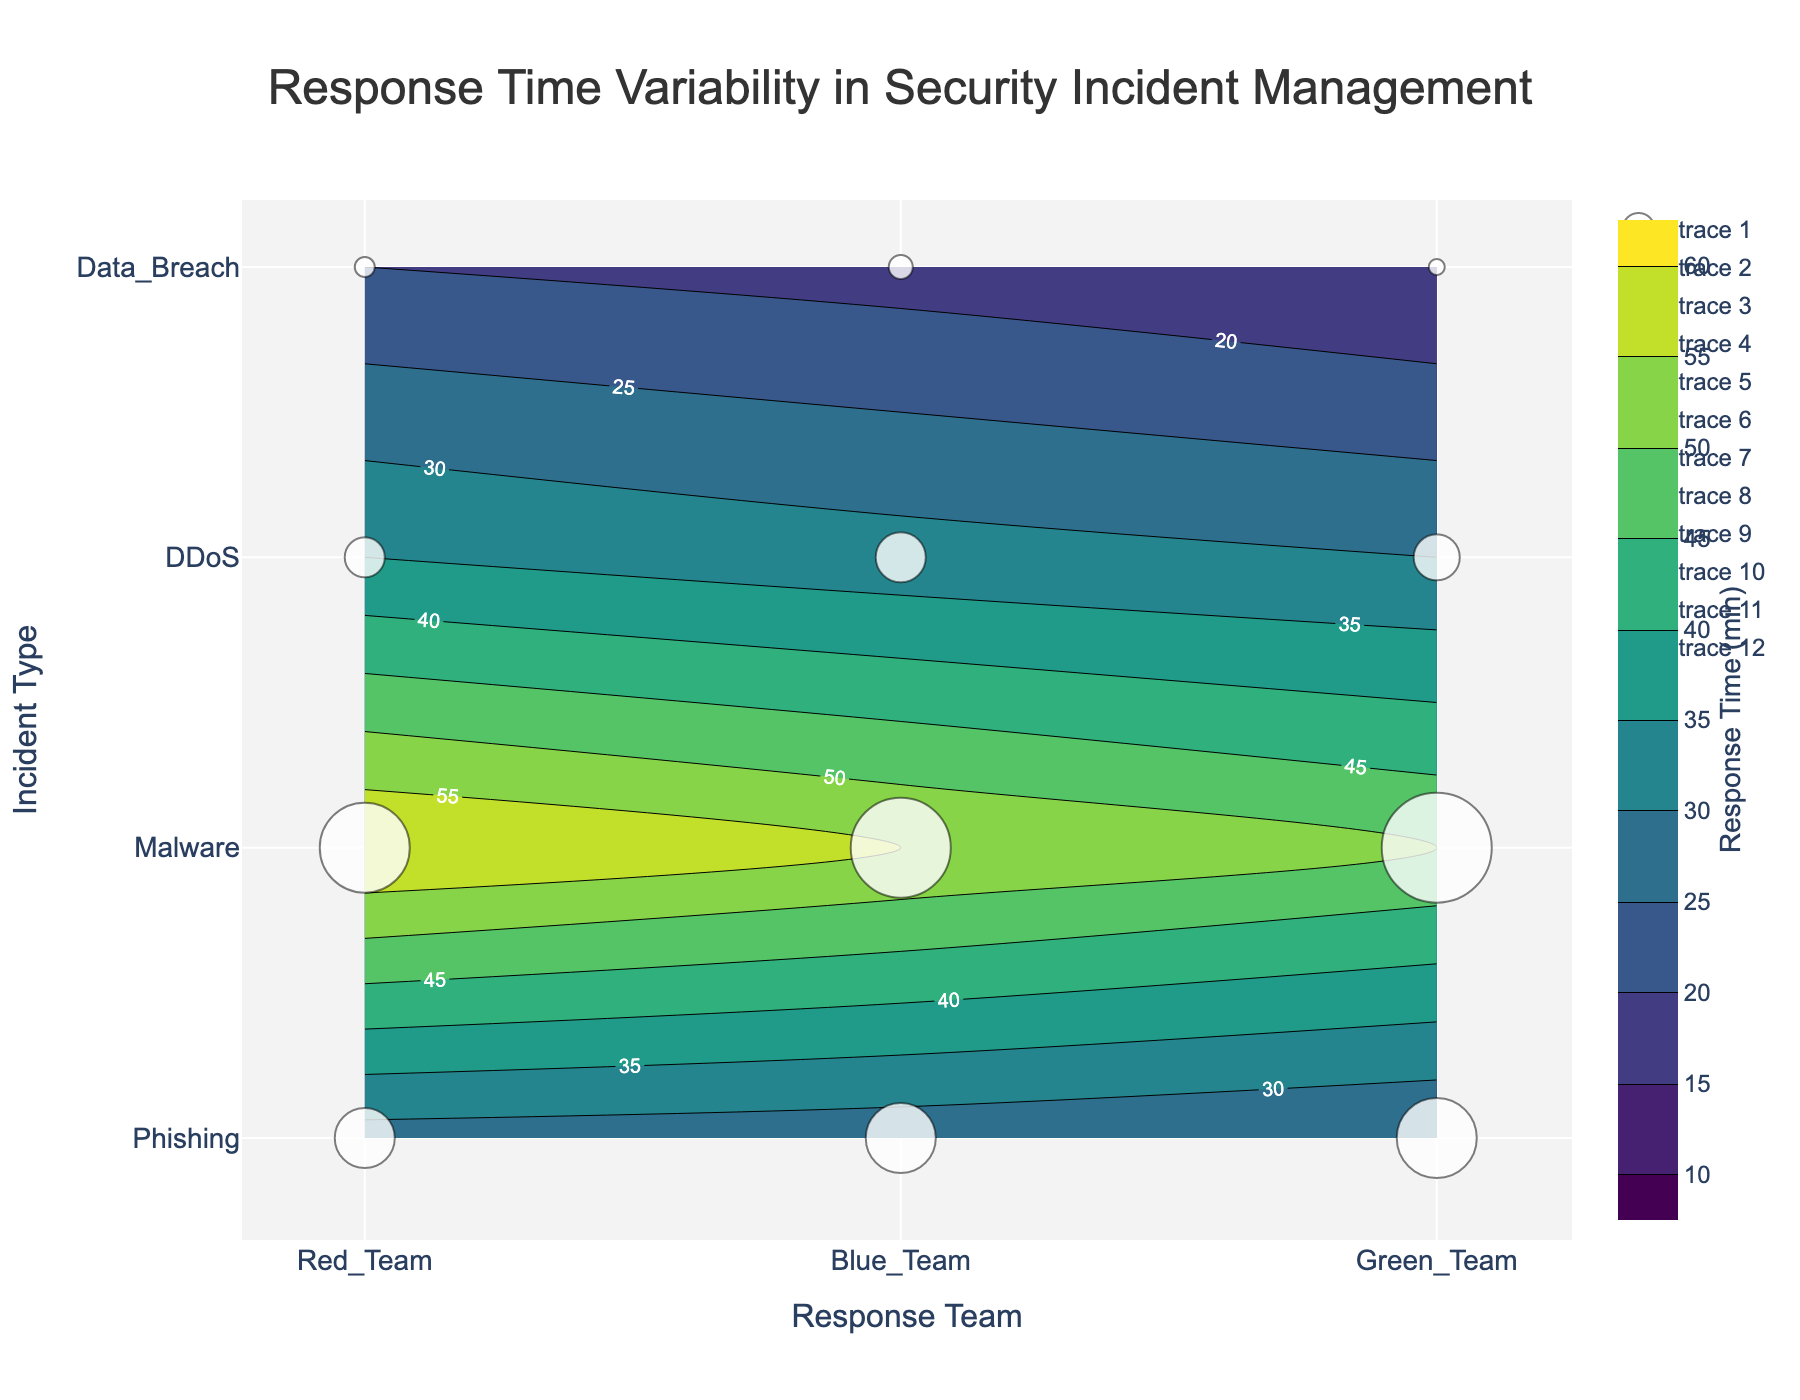What is the title of the figure? The title of the figure is displayed at the top in a larger font size and reads 'Response Time Variability in Security Incident Management'.
Answer: Response Time Variability in Security Incident Management How many response teams are represented in the figure? The x-axis of the contour plot displays the response teams, and there are three labels: Red Team, Blue Team, and Green Team.
Answer: 3 Which incident type has the highest average response time? Looking at the contour colors and labels, Data Breach has the darkest shade, indicating the highest average response time of 50 to 60 minutes.
Answer: Data Breach What are the contour levels displayed in the figure? The contours are marked with labels showing the response times, ranging from 10 to 60 minutes with an interval of 5 minutes.
Answer: 10, 15, 20, 25, 30, 35, 40, 45, 50, 55, 60 What is the average response time of the Green Team for Malware incidents? Locate 'Green Team' on the x-axis and trace it to the 'Malware' incident type on the y-axis. The label at this point indicates an average response time of 32 minutes.
Answer: 32 minutes Which response team has the lowest response time for Phishing incidents? Follow the 'Phishing' incident type from the y-axis and identify that 'Red Team' has an average response time of 15 minutes, which is the lowest in comparison to others.
Answer: Red Team What's the difference in average response time between Red Team and Blue Team for DDoS incidents? Red Team's response time for DDoS is 25 minutes, and Blue Team's is 28 minutes. The difference is calculated as 28 - 25 = 3 minutes.
Answer: 3 minutes Which incident type is handled most frequently by the Blue Team? The size of the markers indicates frequency, and from the scatter plot elements, Blue Team handles Malware incidents most frequently, marked by the largest point.
Answer: Malware Comparing Phishing and Data Breach incidents, by how much does the average response time differ across all response teams? For Phishing: (15 + 20 + 18)/3 = 17.67 minutes. For Data Breach: (50 + 60 + 55)/3 = 55 minutes. The difference is 55 - 17.67 = 37.33 minutes.
Answer: 37.33 minutes Which response team shows the least variance in average response times across different incident types? Observing the contour changes, the Red Team’s contour labels show less variability ranging from 15 to 50 across incident types, compared to other teams which have a broader range.
Answer: Red Team 